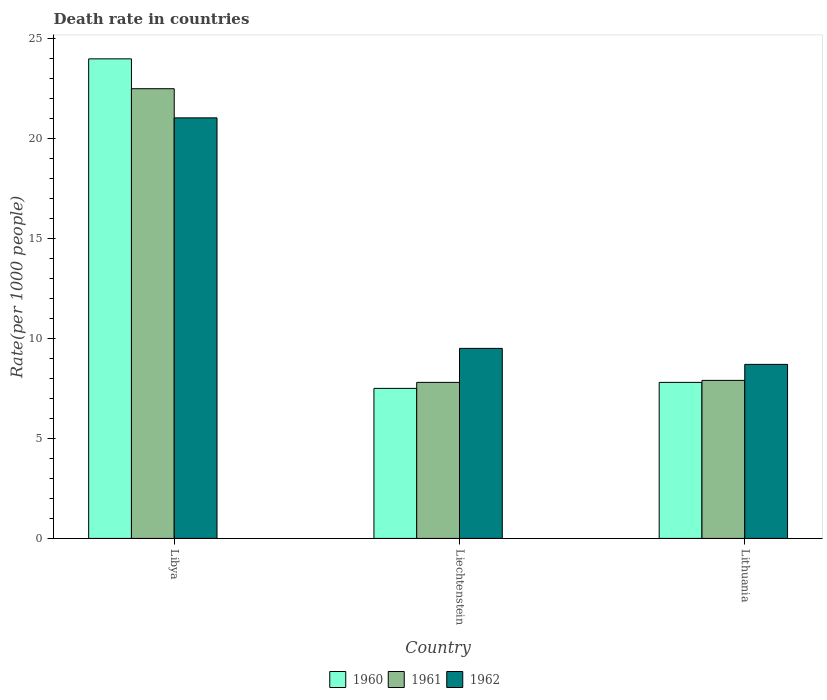How many bars are there on the 3rd tick from the right?
Provide a succinct answer. 3. What is the label of the 1st group of bars from the left?
Provide a succinct answer. Libya. In how many cases, is the number of bars for a given country not equal to the number of legend labels?
Make the answer very short. 0. What is the death rate in 1960 in Liechtenstein?
Keep it short and to the point. 7.5. Across all countries, what is the maximum death rate in 1960?
Provide a succinct answer. 23.97. In which country was the death rate in 1960 maximum?
Your answer should be compact. Libya. In which country was the death rate in 1961 minimum?
Offer a terse response. Liechtenstein. What is the total death rate in 1962 in the graph?
Your answer should be very brief. 39.22. What is the difference between the death rate in 1961 in Libya and that in Liechtenstein?
Your answer should be very brief. 14.68. What is the difference between the death rate in 1962 in Libya and the death rate in 1961 in Liechtenstein?
Offer a very short reply. 13.22. What is the average death rate in 1961 per country?
Make the answer very short. 12.73. What is the difference between the death rate of/in 1960 and death rate of/in 1962 in Liechtenstein?
Your response must be concise. -2. What is the ratio of the death rate in 1962 in Libya to that in Lithuania?
Offer a very short reply. 2.42. What is the difference between the highest and the second highest death rate in 1962?
Keep it short and to the point. -0.8. What is the difference between the highest and the lowest death rate in 1962?
Your answer should be very brief. 12.32. In how many countries, is the death rate in 1961 greater than the average death rate in 1961 taken over all countries?
Give a very brief answer. 1. What does the 1st bar from the left in Liechtenstein represents?
Offer a very short reply. 1960. Is it the case that in every country, the sum of the death rate in 1962 and death rate in 1961 is greater than the death rate in 1960?
Give a very brief answer. Yes. Are all the bars in the graph horizontal?
Make the answer very short. No. Are the values on the major ticks of Y-axis written in scientific E-notation?
Your answer should be compact. No. How many legend labels are there?
Provide a short and direct response. 3. What is the title of the graph?
Offer a terse response. Death rate in countries. Does "2007" appear as one of the legend labels in the graph?
Provide a short and direct response. No. What is the label or title of the X-axis?
Keep it short and to the point. Country. What is the label or title of the Y-axis?
Ensure brevity in your answer.  Rate(per 1000 people). What is the Rate(per 1000 people) of 1960 in Libya?
Your answer should be compact. 23.97. What is the Rate(per 1000 people) of 1961 in Libya?
Your response must be concise. 22.48. What is the Rate(per 1000 people) in 1962 in Libya?
Ensure brevity in your answer.  21.02. What is the Rate(per 1000 people) in 1960 in Lithuania?
Your answer should be very brief. 7.8. What is the Rate(per 1000 people) of 1961 in Lithuania?
Offer a very short reply. 7.9. Across all countries, what is the maximum Rate(per 1000 people) of 1960?
Offer a very short reply. 23.97. Across all countries, what is the maximum Rate(per 1000 people) of 1961?
Offer a very short reply. 22.48. Across all countries, what is the maximum Rate(per 1000 people) in 1962?
Your answer should be very brief. 21.02. Across all countries, what is the minimum Rate(per 1000 people) of 1960?
Your response must be concise. 7.5. What is the total Rate(per 1000 people) of 1960 in the graph?
Offer a very short reply. 39.27. What is the total Rate(per 1000 people) in 1961 in the graph?
Keep it short and to the point. 38.18. What is the total Rate(per 1000 people) of 1962 in the graph?
Offer a terse response. 39.22. What is the difference between the Rate(per 1000 people) of 1960 in Libya and that in Liechtenstein?
Keep it short and to the point. 16.47. What is the difference between the Rate(per 1000 people) of 1961 in Libya and that in Liechtenstein?
Ensure brevity in your answer.  14.68. What is the difference between the Rate(per 1000 people) in 1962 in Libya and that in Liechtenstein?
Provide a succinct answer. 11.52. What is the difference between the Rate(per 1000 people) of 1960 in Libya and that in Lithuania?
Your answer should be compact. 16.17. What is the difference between the Rate(per 1000 people) of 1961 in Libya and that in Lithuania?
Provide a succinct answer. 14.58. What is the difference between the Rate(per 1000 people) in 1962 in Libya and that in Lithuania?
Ensure brevity in your answer.  12.32. What is the difference between the Rate(per 1000 people) of 1961 in Liechtenstein and that in Lithuania?
Your response must be concise. -0.1. What is the difference between the Rate(per 1000 people) in 1962 in Liechtenstein and that in Lithuania?
Provide a short and direct response. 0.8. What is the difference between the Rate(per 1000 people) of 1960 in Libya and the Rate(per 1000 people) of 1961 in Liechtenstein?
Provide a succinct answer. 16.17. What is the difference between the Rate(per 1000 people) in 1960 in Libya and the Rate(per 1000 people) in 1962 in Liechtenstein?
Provide a succinct answer. 14.47. What is the difference between the Rate(per 1000 people) in 1961 in Libya and the Rate(per 1000 people) in 1962 in Liechtenstein?
Provide a succinct answer. 12.98. What is the difference between the Rate(per 1000 people) in 1960 in Libya and the Rate(per 1000 people) in 1961 in Lithuania?
Provide a succinct answer. 16.07. What is the difference between the Rate(per 1000 people) of 1960 in Libya and the Rate(per 1000 people) of 1962 in Lithuania?
Your answer should be compact. 15.27. What is the difference between the Rate(per 1000 people) of 1961 in Libya and the Rate(per 1000 people) of 1962 in Lithuania?
Your answer should be compact. 13.78. What is the difference between the Rate(per 1000 people) in 1960 in Liechtenstein and the Rate(per 1000 people) in 1962 in Lithuania?
Provide a succinct answer. -1.2. What is the difference between the Rate(per 1000 people) in 1961 in Liechtenstein and the Rate(per 1000 people) in 1962 in Lithuania?
Give a very brief answer. -0.9. What is the average Rate(per 1000 people) in 1960 per country?
Your answer should be very brief. 13.09. What is the average Rate(per 1000 people) in 1961 per country?
Provide a short and direct response. 12.73. What is the average Rate(per 1000 people) in 1962 per country?
Your answer should be compact. 13.07. What is the difference between the Rate(per 1000 people) in 1960 and Rate(per 1000 people) in 1961 in Libya?
Offer a terse response. 1.49. What is the difference between the Rate(per 1000 people) in 1960 and Rate(per 1000 people) in 1962 in Libya?
Provide a succinct answer. 2.95. What is the difference between the Rate(per 1000 people) of 1961 and Rate(per 1000 people) of 1962 in Libya?
Provide a succinct answer. 1.46. What is the difference between the Rate(per 1000 people) of 1961 and Rate(per 1000 people) of 1962 in Liechtenstein?
Your answer should be very brief. -1.7. What is the difference between the Rate(per 1000 people) of 1960 and Rate(per 1000 people) of 1961 in Lithuania?
Your answer should be very brief. -0.1. What is the difference between the Rate(per 1000 people) of 1960 and Rate(per 1000 people) of 1962 in Lithuania?
Keep it short and to the point. -0.9. What is the difference between the Rate(per 1000 people) of 1961 and Rate(per 1000 people) of 1962 in Lithuania?
Your answer should be compact. -0.8. What is the ratio of the Rate(per 1000 people) of 1960 in Libya to that in Liechtenstein?
Keep it short and to the point. 3.2. What is the ratio of the Rate(per 1000 people) of 1961 in Libya to that in Liechtenstein?
Provide a short and direct response. 2.88. What is the ratio of the Rate(per 1000 people) in 1962 in Libya to that in Liechtenstein?
Provide a succinct answer. 2.21. What is the ratio of the Rate(per 1000 people) of 1960 in Libya to that in Lithuania?
Provide a short and direct response. 3.07. What is the ratio of the Rate(per 1000 people) of 1961 in Libya to that in Lithuania?
Ensure brevity in your answer.  2.85. What is the ratio of the Rate(per 1000 people) of 1962 in Libya to that in Lithuania?
Your answer should be very brief. 2.42. What is the ratio of the Rate(per 1000 people) in 1960 in Liechtenstein to that in Lithuania?
Make the answer very short. 0.96. What is the ratio of the Rate(per 1000 people) in 1961 in Liechtenstein to that in Lithuania?
Keep it short and to the point. 0.99. What is the ratio of the Rate(per 1000 people) of 1962 in Liechtenstein to that in Lithuania?
Your answer should be very brief. 1.09. What is the difference between the highest and the second highest Rate(per 1000 people) in 1960?
Provide a short and direct response. 16.17. What is the difference between the highest and the second highest Rate(per 1000 people) in 1961?
Your answer should be very brief. 14.58. What is the difference between the highest and the second highest Rate(per 1000 people) of 1962?
Your response must be concise. 11.52. What is the difference between the highest and the lowest Rate(per 1000 people) of 1960?
Give a very brief answer. 16.47. What is the difference between the highest and the lowest Rate(per 1000 people) of 1961?
Keep it short and to the point. 14.68. What is the difference between the highest and the lowest Rate(per 1000 people) in 1962?
Offer a very short reply. 12.32. 